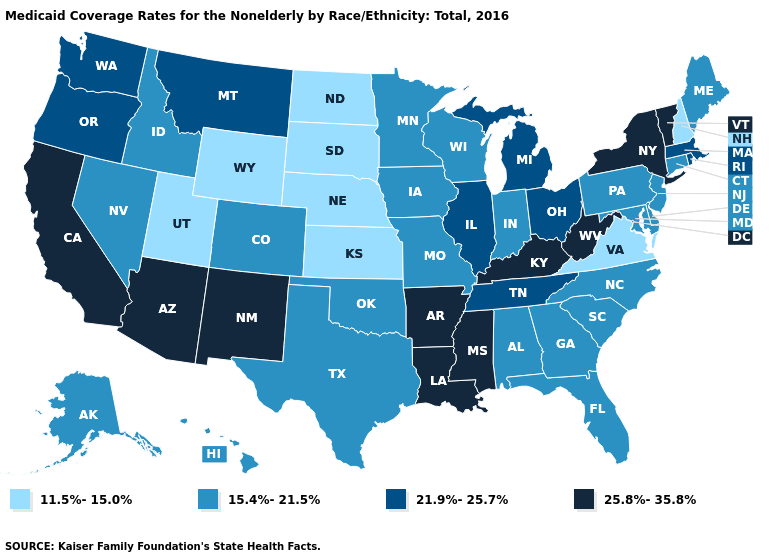Name the states that have a value in the range 25.8%-35.8%?
Keep it brief. Arizona, Arkansas, California, Kentucky, Louisiana, Mississippi, New Mexico, New York, Vermont, West Virginia. Does Washington have the same value as Montana?
Quick response, please. Yes. Does New Hampshire have the lowest value in the USA?
Be succinct. Yes. Among the states that border Kansas , does Missouri have the highest value?
Quick response, please. Yes. Name the states that have a value in the range 21.9%-25.7%?
Keep it brief. Illinois, Massachusetts, Michigan, Montana, Ohio, Oregon, Rhode Island, Tennessee, Washington. Does West Virginia have the highest value in the USA?
Keep it brief. Yes. Does Rhode Island have the lowest value in the USA?
Keep it brief. No. What is the value of Alabama?
Concise answer only. 15.4%-21.5%. What is the value of Kansas?
Give a very brief answer. 11.5%-15.0%. Name the states that have a value in the range 11.5%-15.0%?
Give a very brief answer. Kansas, Nebraska, New Hampshire, North Dakota, South Dakota, Utah, Virginia, Wyoming. Name the states that have a value in the range 21.9%-25.7%?
Be succinct. Illinois, Massachusetts, Michigan, Montana, Ohio, Oregon, Rhode Island, Tennessee, Washington. Among the states that border Colorado , which have the highest value?
Quick response, please. Arizona, New Mexico. Name the states that have a value in the range 25.8%-35.8%?
Keep it brief. Arizona, Arkansas, California, Kentucky, Louisiana, Mississippi, New Mexico, New York, Vermont, West Virginia. What is the value of Georgia?
Write a very short answer. 15.4%-21.5%. Does Utah have the lowest value in the USA?
Quick response, please. Yes. 